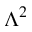<formula> <loc_0><loc_0><loc_500><loc_500>\Lambda ^ { 2 }</formula> 